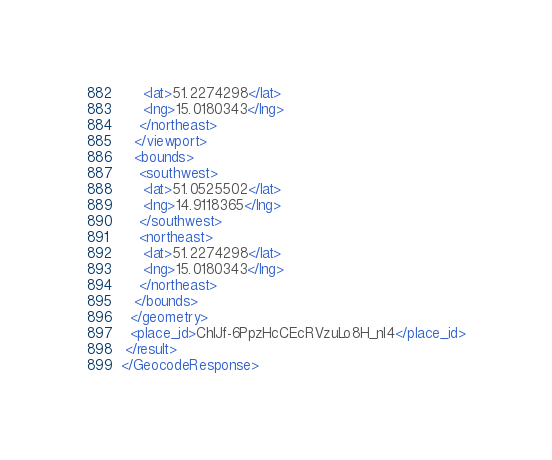Convert code to text. <code><loc_0><loc_0><loc_500><loc_500><_XML_>     <lat>51.2274298</lat>
     <lng>15.0180343</lng>
    </northeast>
   </viewport>
   <bounds>
    <southwest>
     <lat>51.0525502</lat>
     <lng>14.9118365</lng>
    </southwest>
    <northeast>
     <lat>51.2274298</lat>
     <lng>15.0180343</lng>
    </northeast>
   </bounds>
  </geometry>
  <place_id>ChIJf-6PpzHcCEcRVzuLo8H_nl4</place_id>
 </result>
</GeocodeResponse>
</code> 